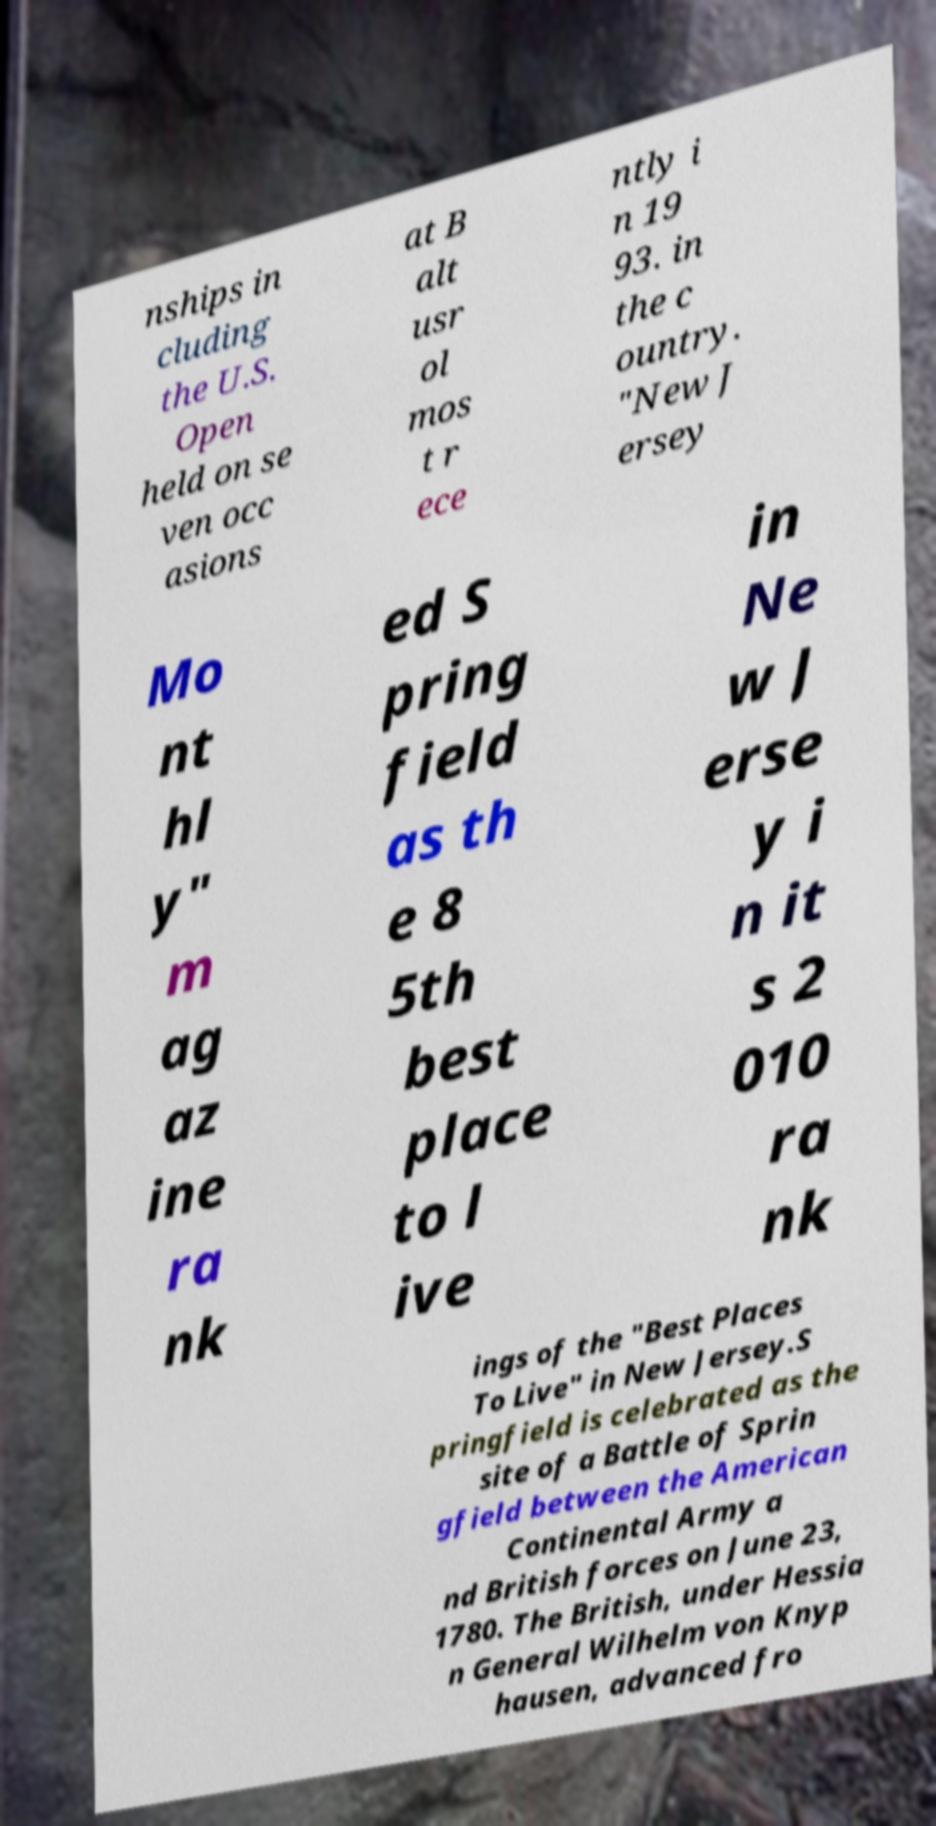Please read and relay the text visible in this image. What does it say? nships in cluding the U.S. Open held on se ven occ asions at B alt usr ol mos t r ece ntly i n 19 93. in the c ountry. "New J ersey Mo nt hl y" m ag az ine ra nk ed S pring field as th e 8 5th best place to l ive in Ne w J erse y i n it s 2 010 ra nk ings of the "Best Places To Live" in New Jersey.S pringfield is celebrated as the site of a Battle of Sprin gfield between the American Continental Army a nd British forces on June 23, 1780. The British, under Hessia n General Wilhelm von Knyp hausen, advanced fro 